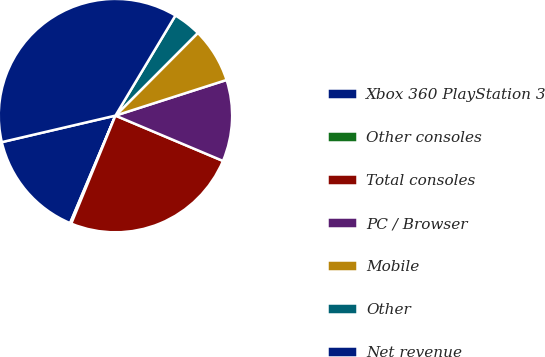Convert chart. <chart><loc_0><loc_0><loc_500><loc_500><pie_chart><fcel>Xbox 360 PlayStation 3<fcel>Other consoles<fcel>Total consoles<fcel>PC / Browser<fcel>Mobile<fcel>Other<fcel>Net revenue<nl><fcel>15.0%<fcel>0.17%<fcel>24.83%<fcel>11.29%<fcel>7.59%<fcel>3.88%<fcel>37.24%<nl></chart> 